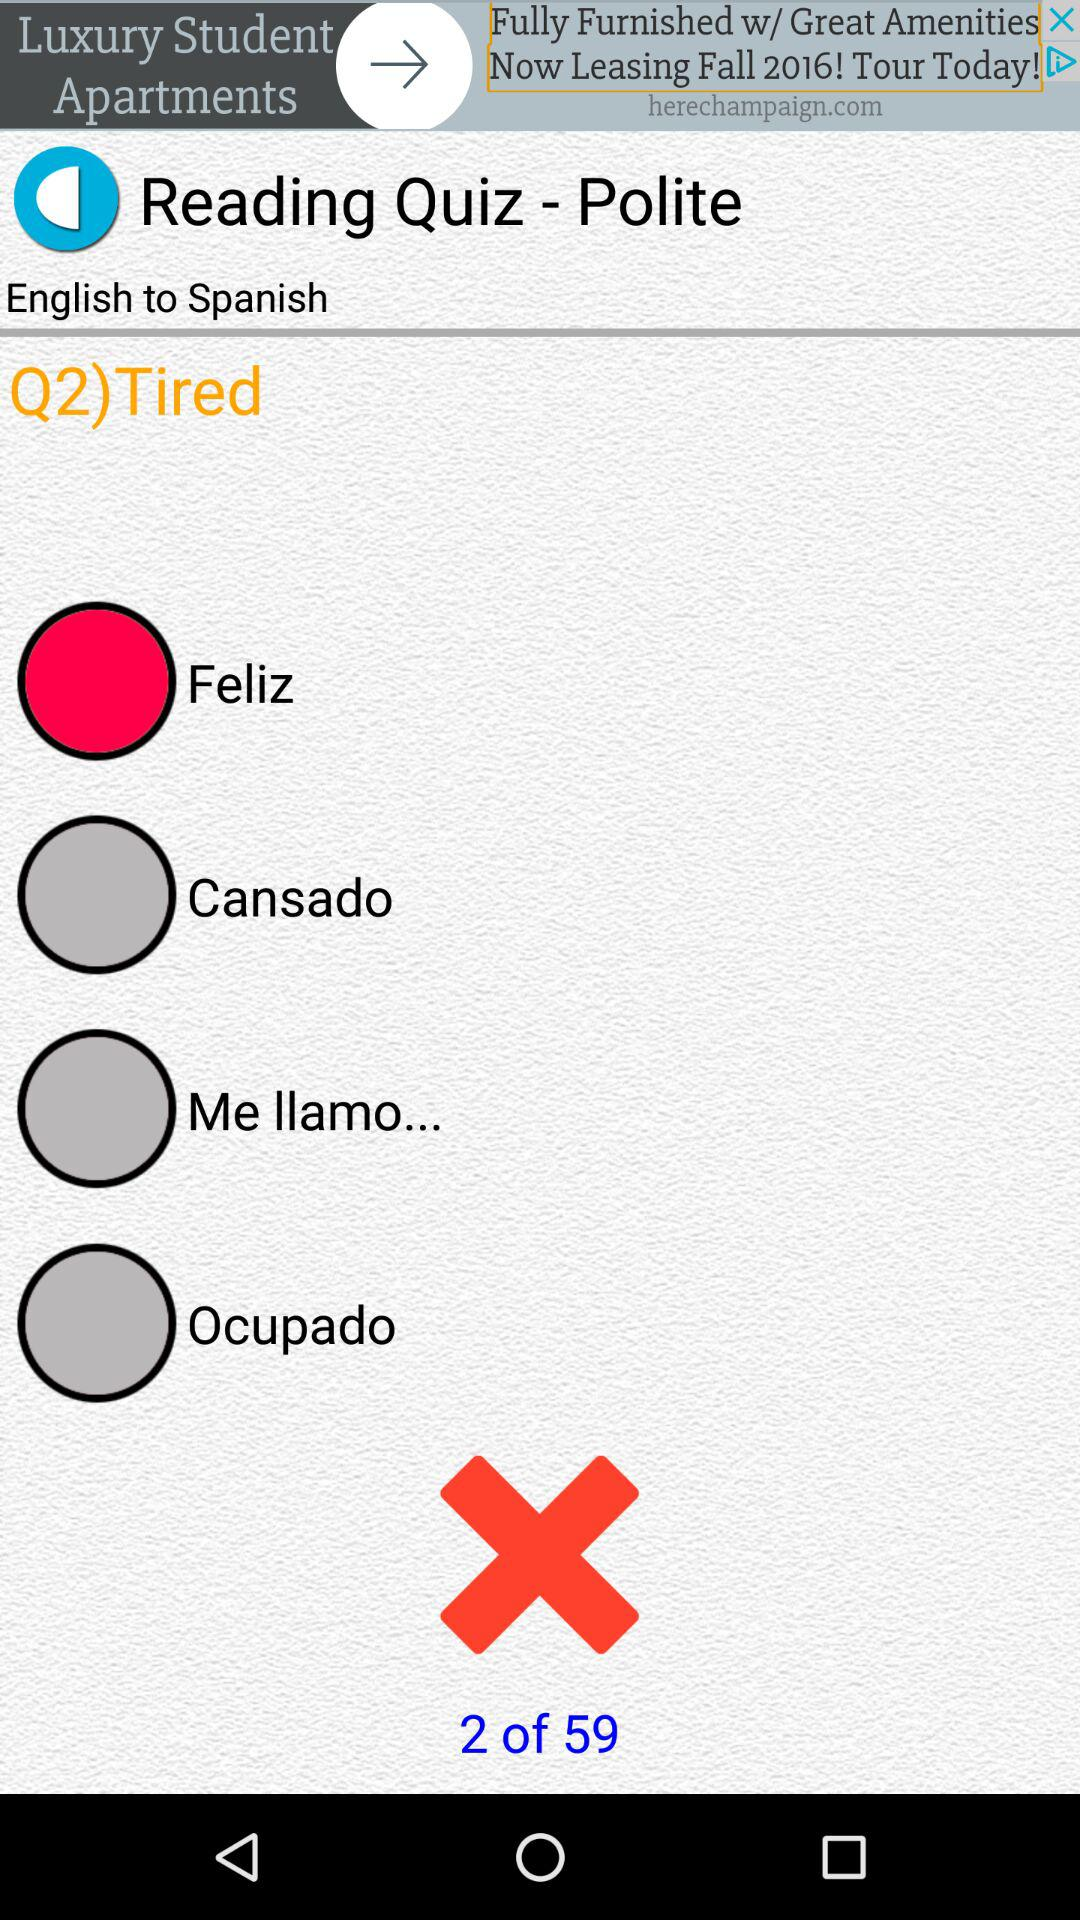Which option is selected? The selected option is "Feliz". 